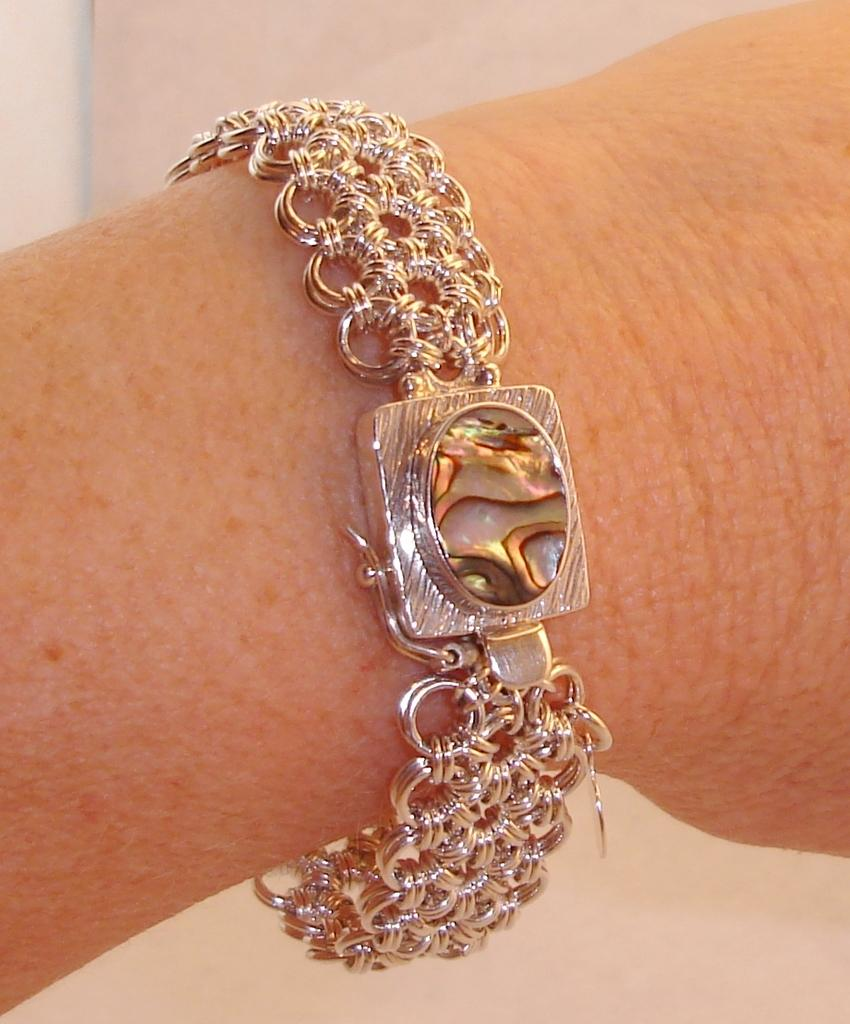What is the focus of the image? The image is a zoomed-in view. What can be seen in the image? There is a person's bracelet in the image. Where is the bracelet located on the person? The bracelet is on the person's hand. What type of reaction can be seen from the clover in the image? There is no clover present in the image, so it is not possible to determine any reaction from a clover. 